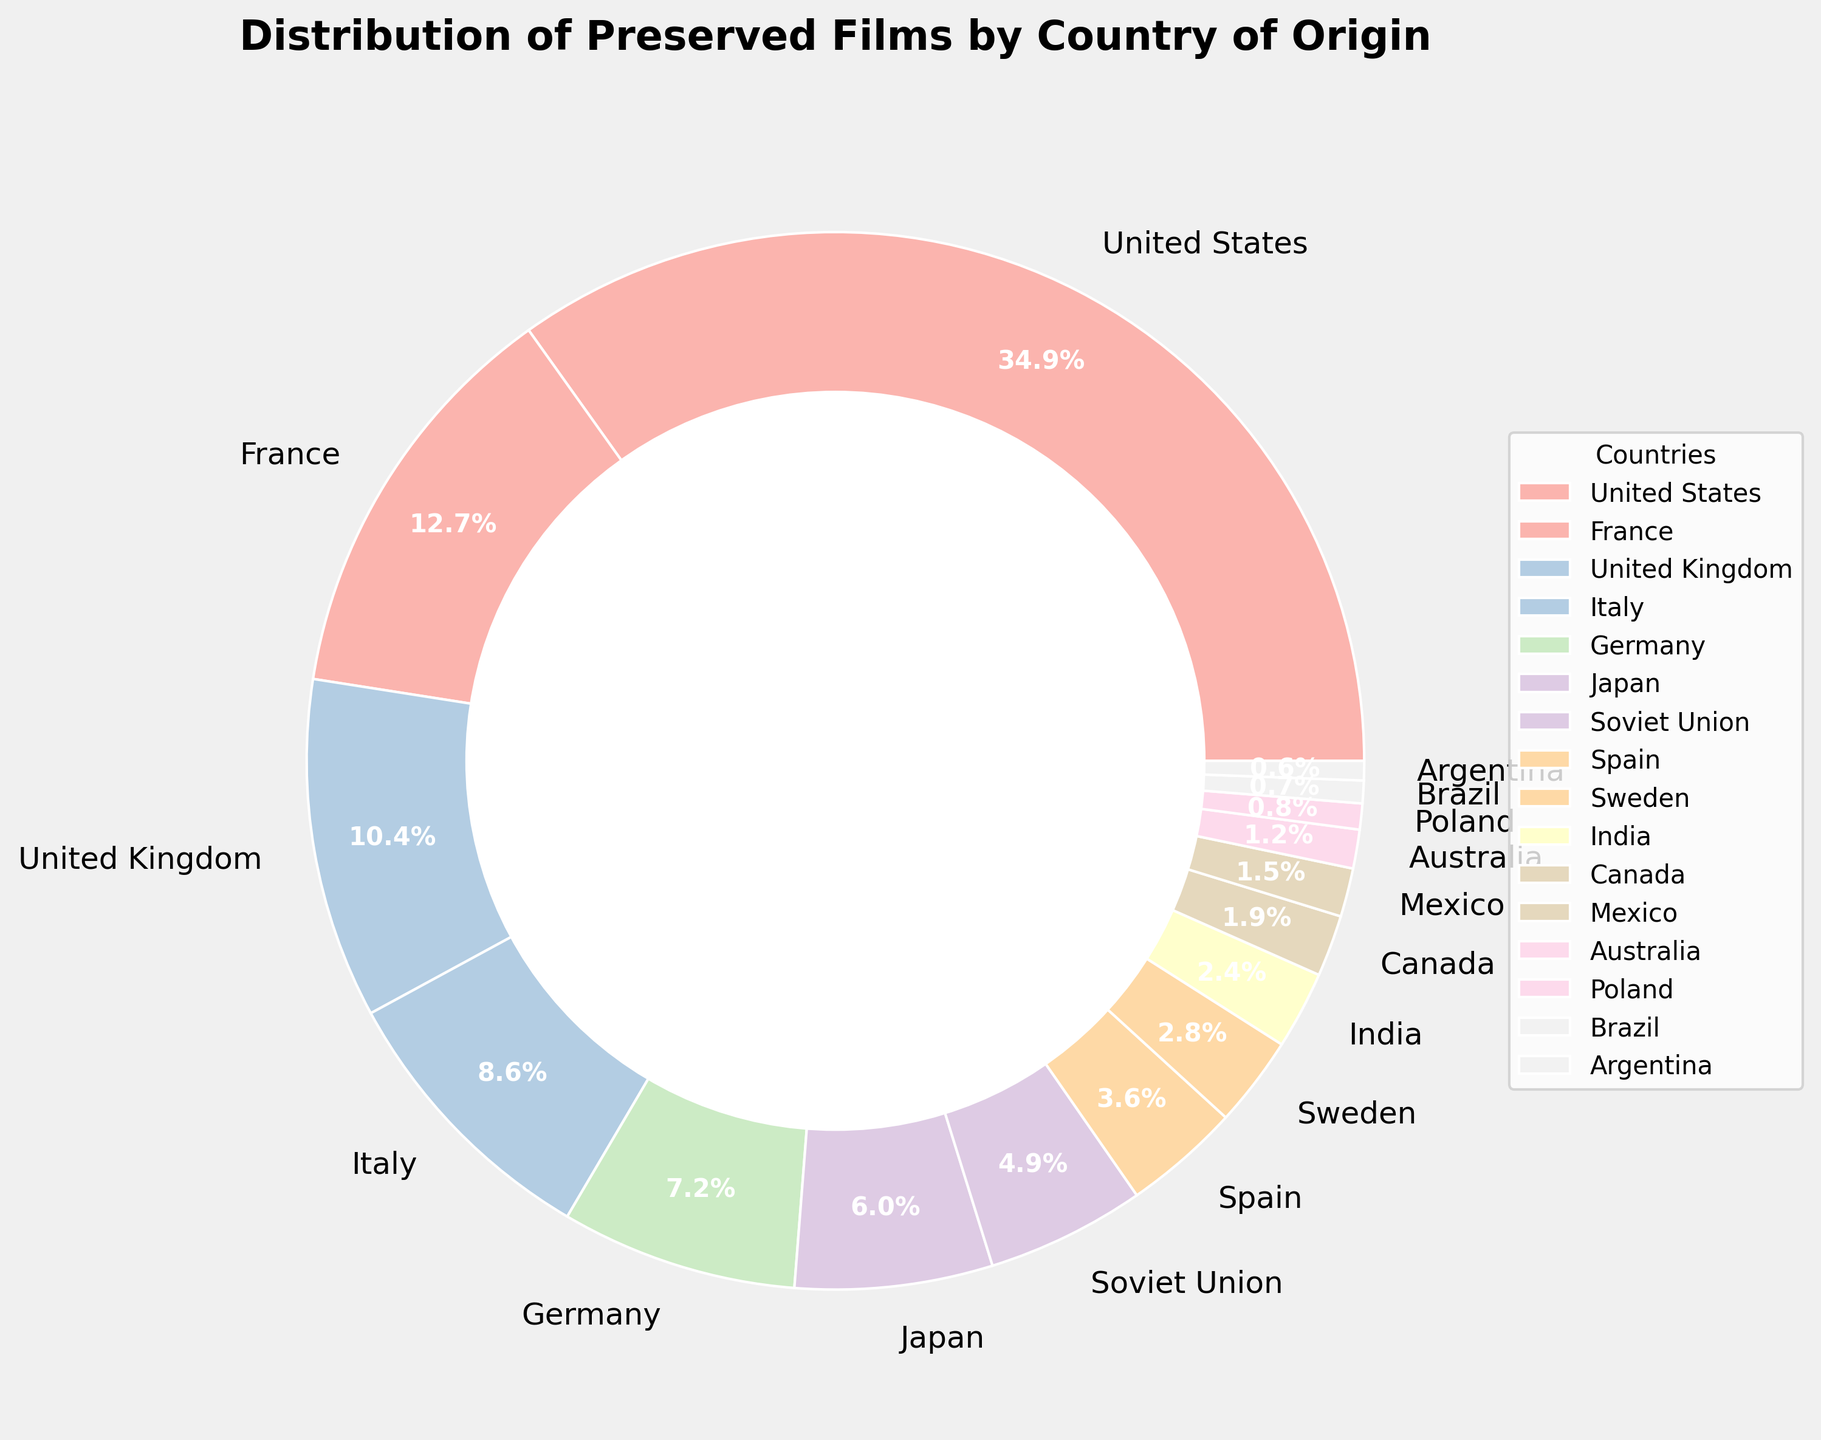Which country has the highest percentage of preserved films? The pie chart shows that the United States has the largest slice, labeled 35.2%. Therefore, the United States has the highest percentage of preserved films.
Answer: United States Which two countries combined represent over 45% of the preserved films? Adding the percentages of the United States (35.2%) and France (12.8%) gives a total of 48%. Since 48% is greater than 45%, the United States and France combined represent over 45% of the preserved films.
Answer: United States and France What is the difference in preserved films percentage between the United States and Japan? The United States has 35.2% and Japan has 6.1%. Subtracting Japan's percentage from the United States' percentage gives 35.2% - 6.1% = 29.1%.
Answer: 29.1% Which three countries contribute the least to the preserved films percentage? The countries with the smallest slices in the pie chart are Brazil (0.7%), Poland (0.8%), and Argentina (0.6%).
Answer: Brazil, Poland, and Argentina Are there any countries with a preserved films percentage lower than 2%? The pie chart shows that the countries with percentages lower than 2% are Canada (1.9%), Mexico (1.5%), Australia (1.2%), Poland (0.8%), Brazil (0.7%), and Argentina (0.6%).
Answer: Yes What is the total percentage of preserved films from European countries (United Kingdom, France, Italy, Germany, Spain, Sweden, and Poland)? Adding the percentages of the listed European countries: United Kingdom (10.5%) + France (12.8%) + Italy (8.7%) + Germany (7.3%) + Spain (3.6%) + Sweden (2.8%) + Poland (0.8%) = 46.5%.
Answer: 46.5% Which country has slightly more preserved films than Spain? Spain is labeled with 3.6%. The country with a percentage slightly above this is Sweden with 2.8%. However, Spain has more than Sweden, so the next country slightly above Spain's is the Soviet Union with 4.9%.
Answer: Soviet Union What is the combined percentage of preserved films from countries with less than 5% each? Combining the percentages of Soviet Union (4.9%), Spain (3.6%), Sweden (2.8%), India (2.4%), Canada (1.9%), Mexico (1.5%), Australia (1.2%), Poland (0.8%), Brazil (0.7%), and Argentina (0.6%): 4.9% + 3.6% + 2.8% + 2.4% + 1.9% + 1.5% + 1.2% + 0.8% + 0.7% + 0.6% = 20.4%.
Answer: 20.4% What is the average percentage of preserved films for France, the United Kingdom, and Italy? Adding the percentages: France (12.8%) + United Kingdom (10.5%) + Italy (8.7%) = 32%. Then dividing by the number of countries (3): 32/3 = 10.67%.
Answer: 10.67% 